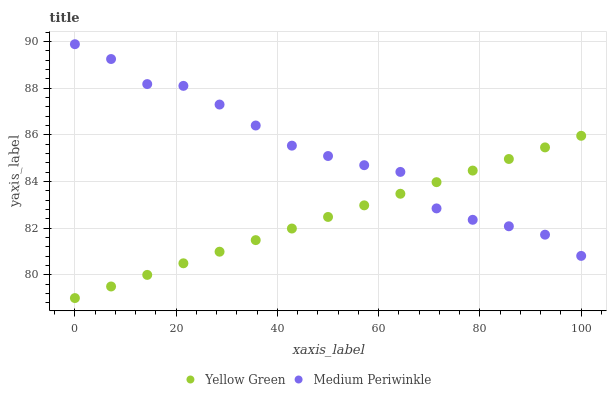Does Yellow Green have the minimum area under the curve?
Answer yes or no. Yes. Does Medium Periwinkle have the maximum area under the curve?
Answer yes or no. Yes. Does Yellow Green have the maximum area under the curve?
Answer yes or no. No. Is Yellow Green the smoothest?
Answer yes or no. Yes. Is Medium Periwinkle the roughest?
Answer yes or no. Yes. Is Yellow Green the roughest?
Answer yes or no. No. Does Yellow Green have the lowest value?
Answer yes or no. Yes. Does Medium Periwinkle have the highest value?
Answer yes or no. Yes. Does Yellow Green have the highest value?
Answer yes or no. No. Does Yellow Green intersect Medium Periwinkle?
Answer yes or no. Yes. Is Yellow Green less than Medium Periwinkle?
Answer yes or no. No. Is Yellow Green greater than Medium Periwinkle?
Answer yes or no. No. 